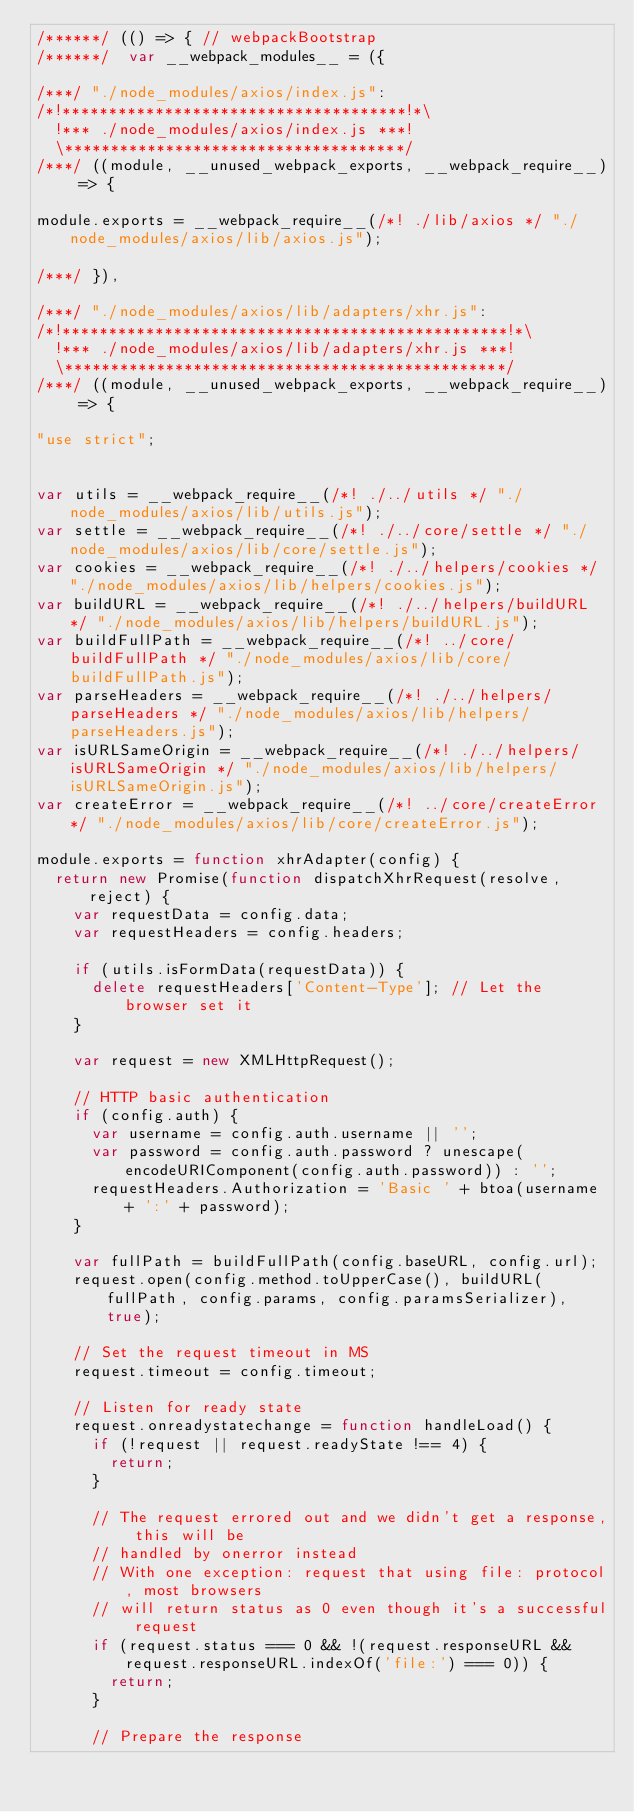Convert code to text. <code><loc_0><loc_0><loc_500><loc_500><_JavaScript_>/******/ (() => { // webpackBootstrap
/******/ 	var __webpack_modules__ = ({

/***/ "./node_modules/axios/index.js":
/*!*************************************!*\
  !*** ./node_modules/axios/index.js ***!
  \*************************************/
/***/ ((module, __unused_webpack_exports, __webpack_require__) => {

module.exports = __webpack_require__(/*! ./lib/axios */ "./node_modules/axios/lib/axios.js");

/***/ }),

/***/ "./node_modules/axios/lib/adapters/xhr.js":
/*!************************************************!*\
  !*** ./node_modules/axios/lib/adapters/xhr.js ***!
  \************************************************/
/***/ ((module, __unused_webpack_exports, __webpack_require__) => {

"use strict";


var utils = __webpack_require__(/*! ./../utils */ "./node_modules/axios/lib/utils.js");
var settle = __webpack_require__(/*! ./../core/settle */ "./node_modules/axios/lib/core/settle.js");
var cookies = __webpack_require__(/*! ./../helpers/cookies */ "./node_modules/axios/lib/helpers/cookies.js");
var buildURL = __webpack_require__(/*! ./../helpers/buildURL */ "./node_modules/axios/lib/helpers/buildURL.js");
var buildFullPath = __webpack_require__(/*! ../core/buildFullPath */ "./node_modules/axios/lib/core/buildFullPath.js");
var parseHeaders = __webpack_require__(/*! ./../helpers/parseHeaders */ "./node_modules/axios/lib/helpers/parseHeaders.js");
var isURLSameOrigin = __webpack_require__(/*! ./../helpers/isURLSameOrigin */ "./node_modules/axios/lib/helpers/isURLSameOrigin.js");
var createError = __webpack_require__(/*! ../core/createError */ "./node_modules/axios/lib/core/createError.js");

module.exports = function xhrAdapter(config) {
  return new Promise(function dispatchXhrRequest(resolve, reject) {
    var requestData = config.data;
    var requestHeaders = config.headers;

    if (utils.isFormData(requestData)) {
      delete requestHeaders['Content-Type']; // Let the browser set it
    }

    var request = new XMLHttpRequest();

    // HTTP basic authentication
    if (config.auth) {
      var username = config.auth.username || '';
      var password = config.auth.password ? unescape(encodeURIComponent(config.auth.password)) : '';
      requestHeaders.Authorization = 'Basic ' + btoa(username + ':' + password);
    }

    var fullPath = buildFullPath(config.baseURL, config.url);
    request.open(config.method.toUpperCase(), buildURL(fullPath, config.params, config.paramsSerializer), true);

    // Set the request timeout in MS
    request.timeout = config.timeout;

    // Listen for ready state
    request.onreadystatechange = function handleLoad() {
      if (!request || request.readyState !== 4) {
        return;
      }

      // The request errored out and we didn't get a response, this will be
      // handled by onerror instead
      // With one exception: request that using file: protocol, most browsers
      // will return status as 0 even though it's a successful request
      if (request.status === 0 && !(request.responseURL && request.responseURL.indexOf('file:') === 0)) {
        return;
      }

      // Prepare the response</code> 